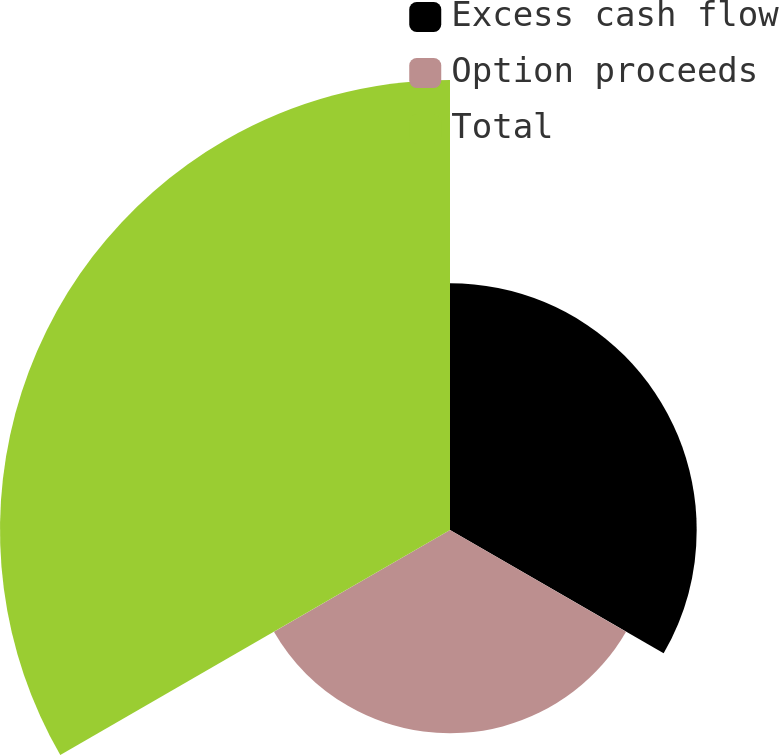Convert chart to OTSL. <chart><loc_0><loc_0><loc_500><loc_500><pie_chart><fcel>Excess cash flow<fcel>Option proceeds<fcel>Total<nl><fcel>27.41%<fcel>22.59%<fcel>50.0%<nl></chart> 